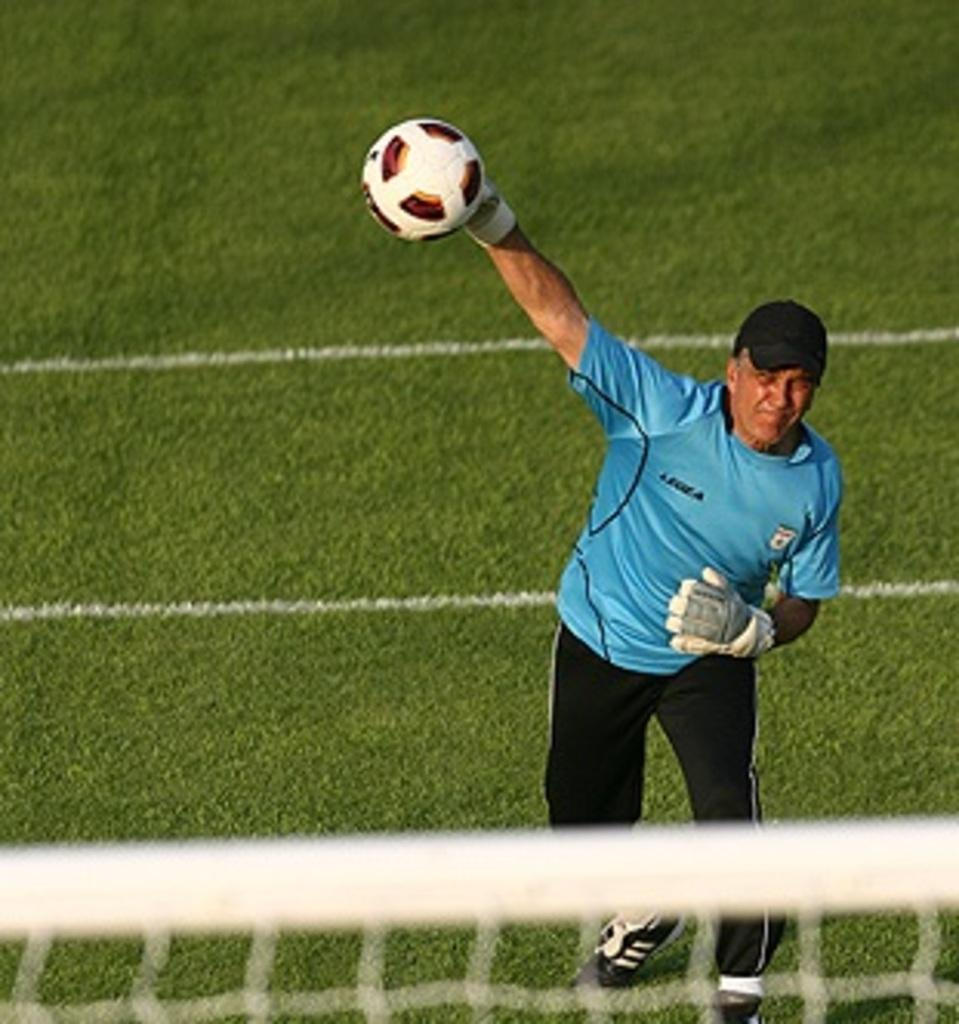What is the man in the image doing? The man is throwing a ball in the image. What is the man wearing on his upper body? The man is wearing a blue t-shirt. What is the man wearing on his lower body? The man is wearing black trousers. What type of footwear is the man wearing? The man is wearing shoes. What can be seen at the bottom of the image? There is a net at the bottom of the image. What is the ground surface like in the image? The ground is covered with grass. How many people are wearing vests in the image? There is no mention of a vest or any other person in the image, so it cannot be determined. What type of group activity is the man participating in with the ball? The image does not provide enough information to determine if the man is participating in a group activity. 